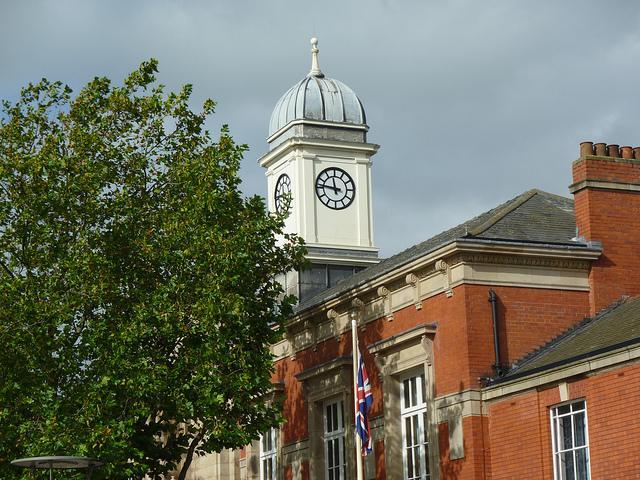What color is the clock tower?
Answer briefly. White. What is the steeple shaped like?
Give a very brief answer. Dome. What color is the building?
Give a very brief answer. Brown. Do the trees have leaves?
Quick response, please. Yes. What color is the cupola?
Keep it brief. White. What time is it in the picture?
Write a very short answer. 11:46. What building is this?
Keep it brief. City hall. Is it day or night?
Answer briefly. Day. What time does the clock show?
Be succinct. 11:45. What time does the clock say?
Be succinct. 11:46. Is it going to rain?
Quick response, please. Yes. What time is it?
Concise answer only. 11:46. Is there a clock on the tower?
Answer briefly. Yes. 